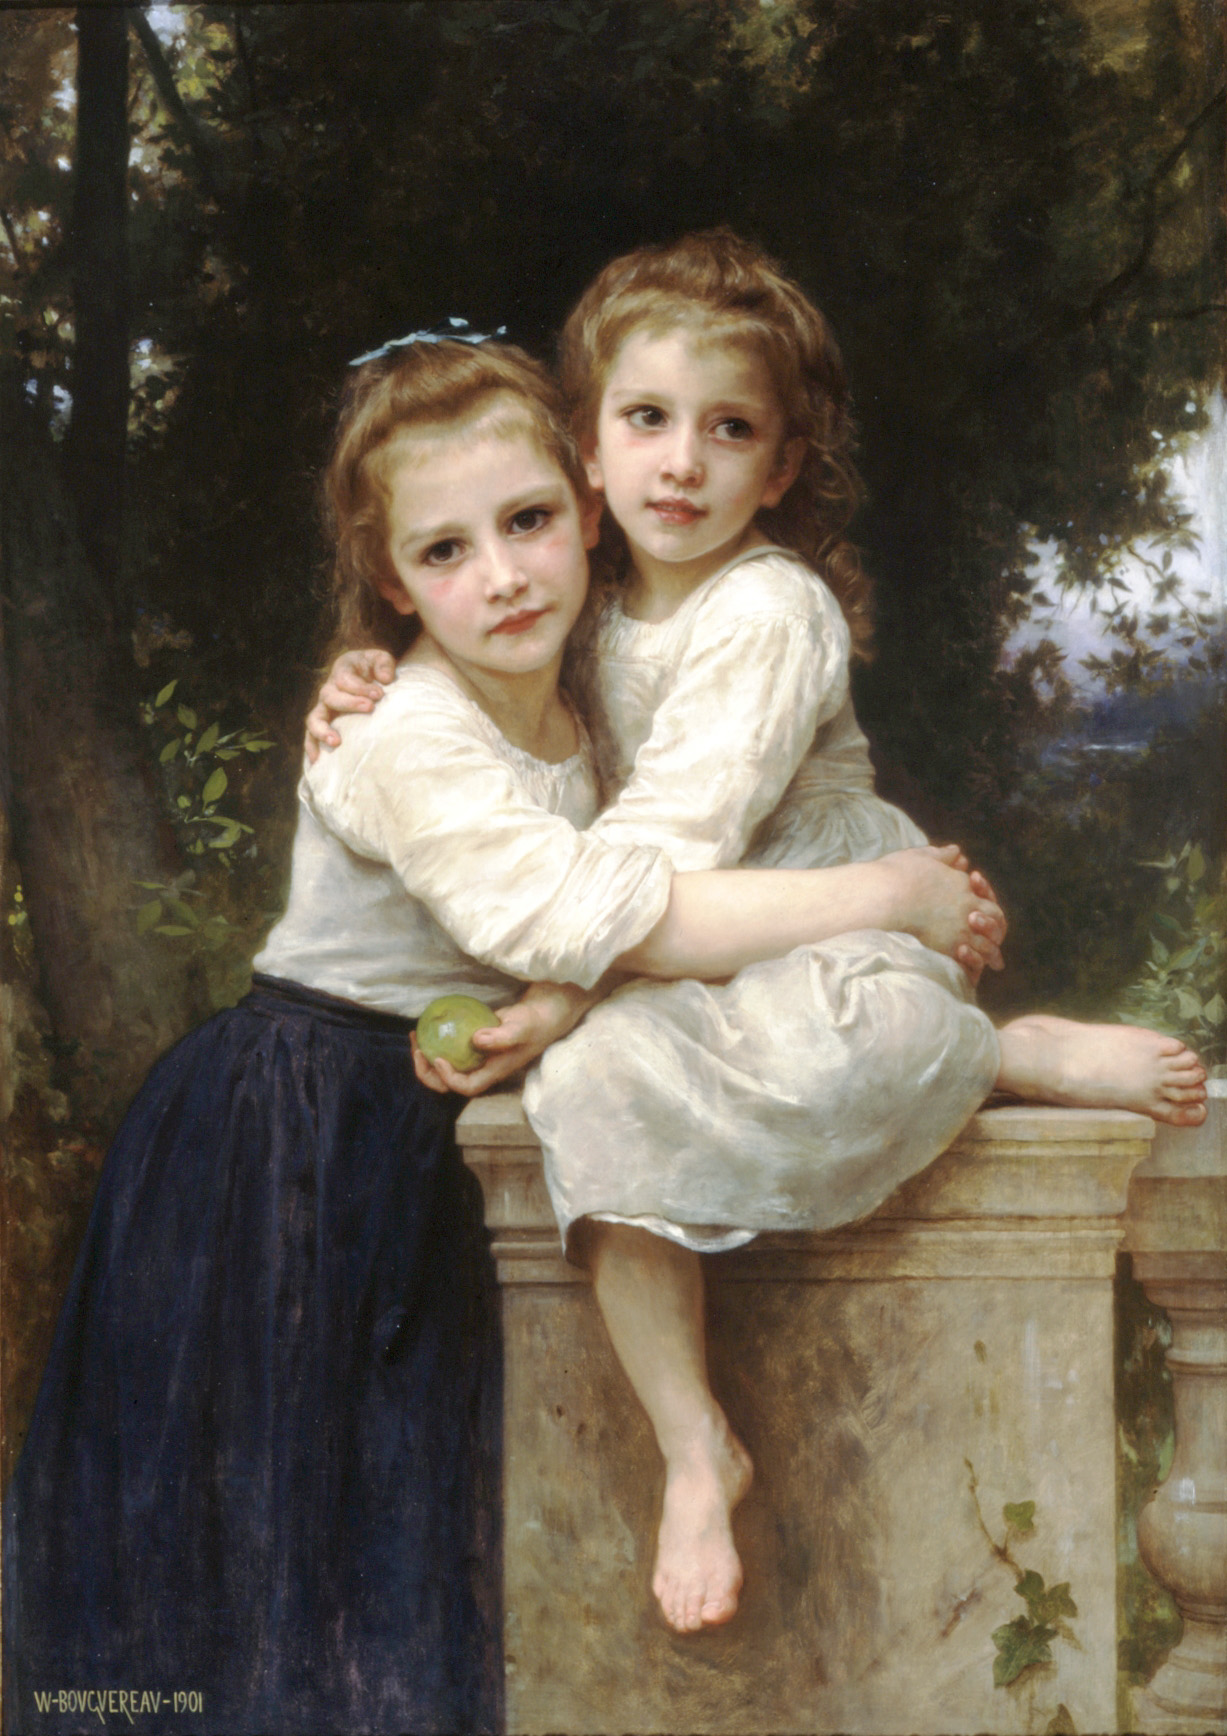Can you describe the main features of this image for me? Certainly, the image is an exquisite oil painting that captures a moment of affectionate intimacy between two children, likely sisters, based on their resemblance. They are seated on an architectural stone ledge, which adds a classical touch to the scene. The girl on the left wears a navy skirt with a light blue blouse, holding a green apple that provides a splash of color against the subdued palette. The girl on the right is dressed in an off-white dress that spills over the ledge in gentle folds. Their expressions are serene and content, with the faintest hint of a smile on the elder child's face, suggesting a heartfelt bond between them. A soft, diffuse light bathes the scene, highlighting the texture of their clothes, the smoothness of their skin, and the nuanced shading that gives the image depth. The lush background, with hints of a blue sky through the trees, imparts a peaceful, idyllic quality to the painting. The piece, clearly executed by a skilled artist, displays a mastery of realism, with particular attention to the play of light, shadow, and texture, inviting viewers into a serene, timeless world. 